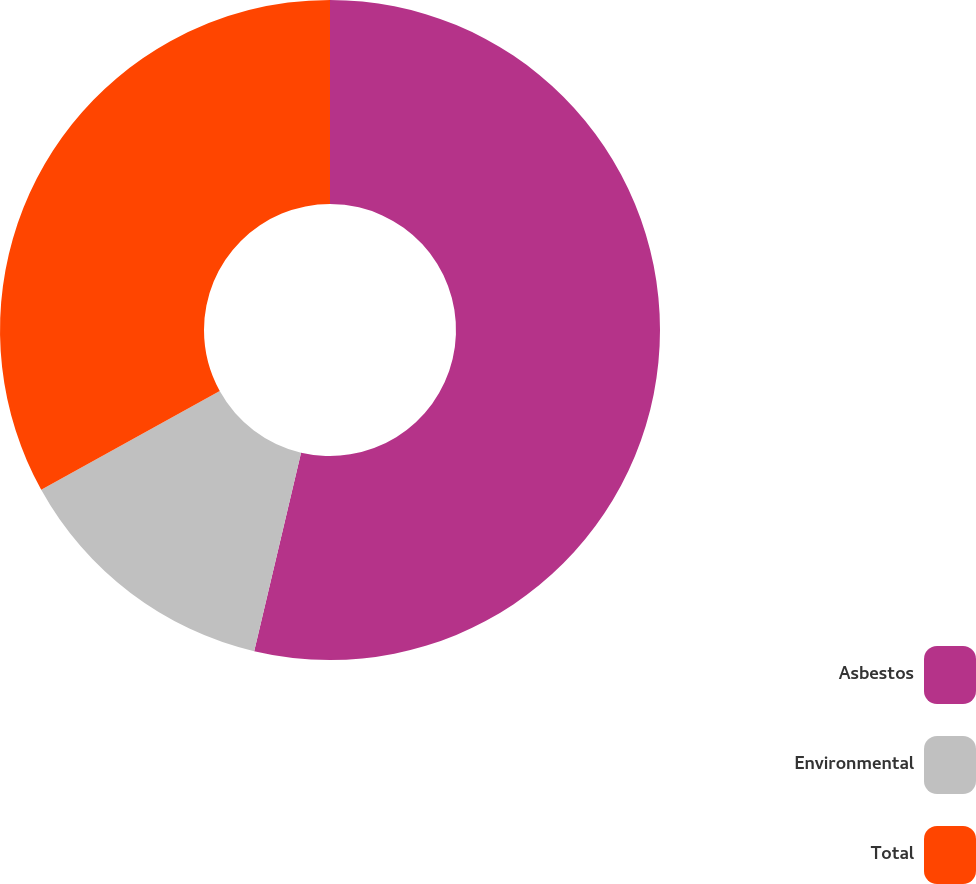<chart> <loc_0><loc_0><loc_500><loc_500><pie_chart><fcel>Asbestos<fcel>Environmental<fcel>Total<nl><fcel>53.69%<fcel>13.27%<fcel>33.04%<nl></chart> 